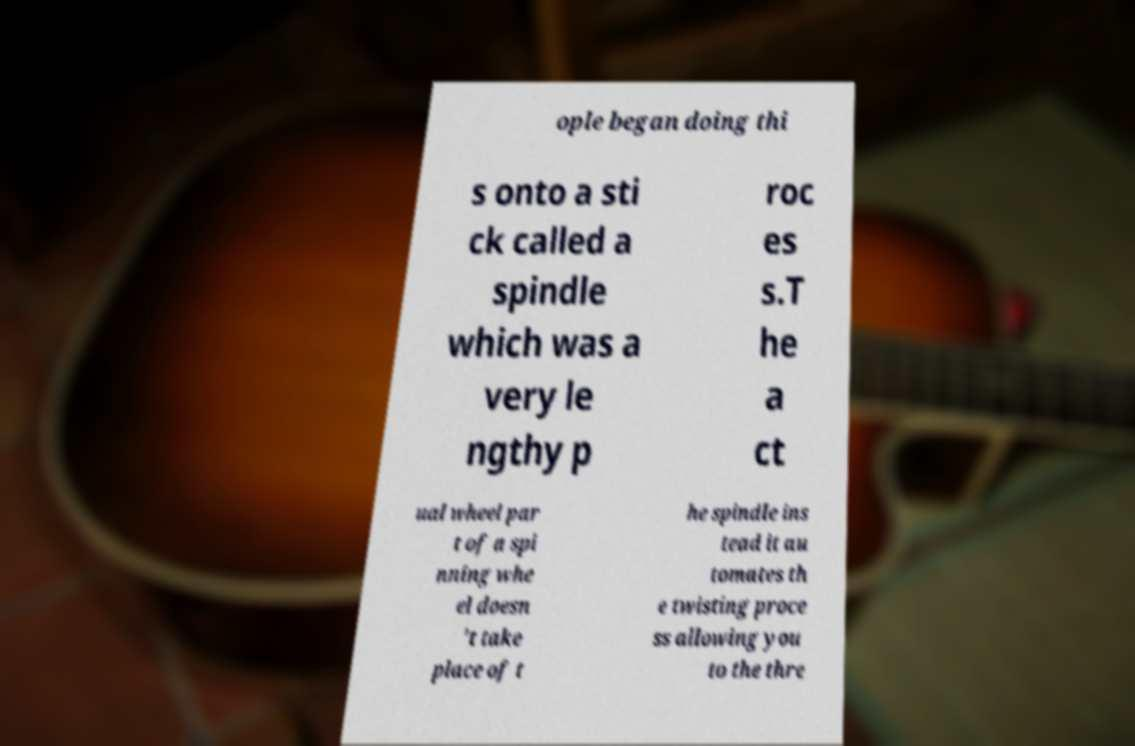Can you accurately transcribe the text from the provided image for me? ople began doing thi s onto a sti ck called a spindle which was a very le ngthy p roc es s.T he a ct ual wheel par t of a spi nning whe el doesn 't take place of t he spindle ins tead it au tomates th e twisting proce ss allowing you to the thre 